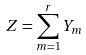Convert formula to latex. <formula><loc_0><loc_0><loc_500><loc_500>Z = \sum _ { m = 1 } ^ { r } Y _ { m }</formula> 